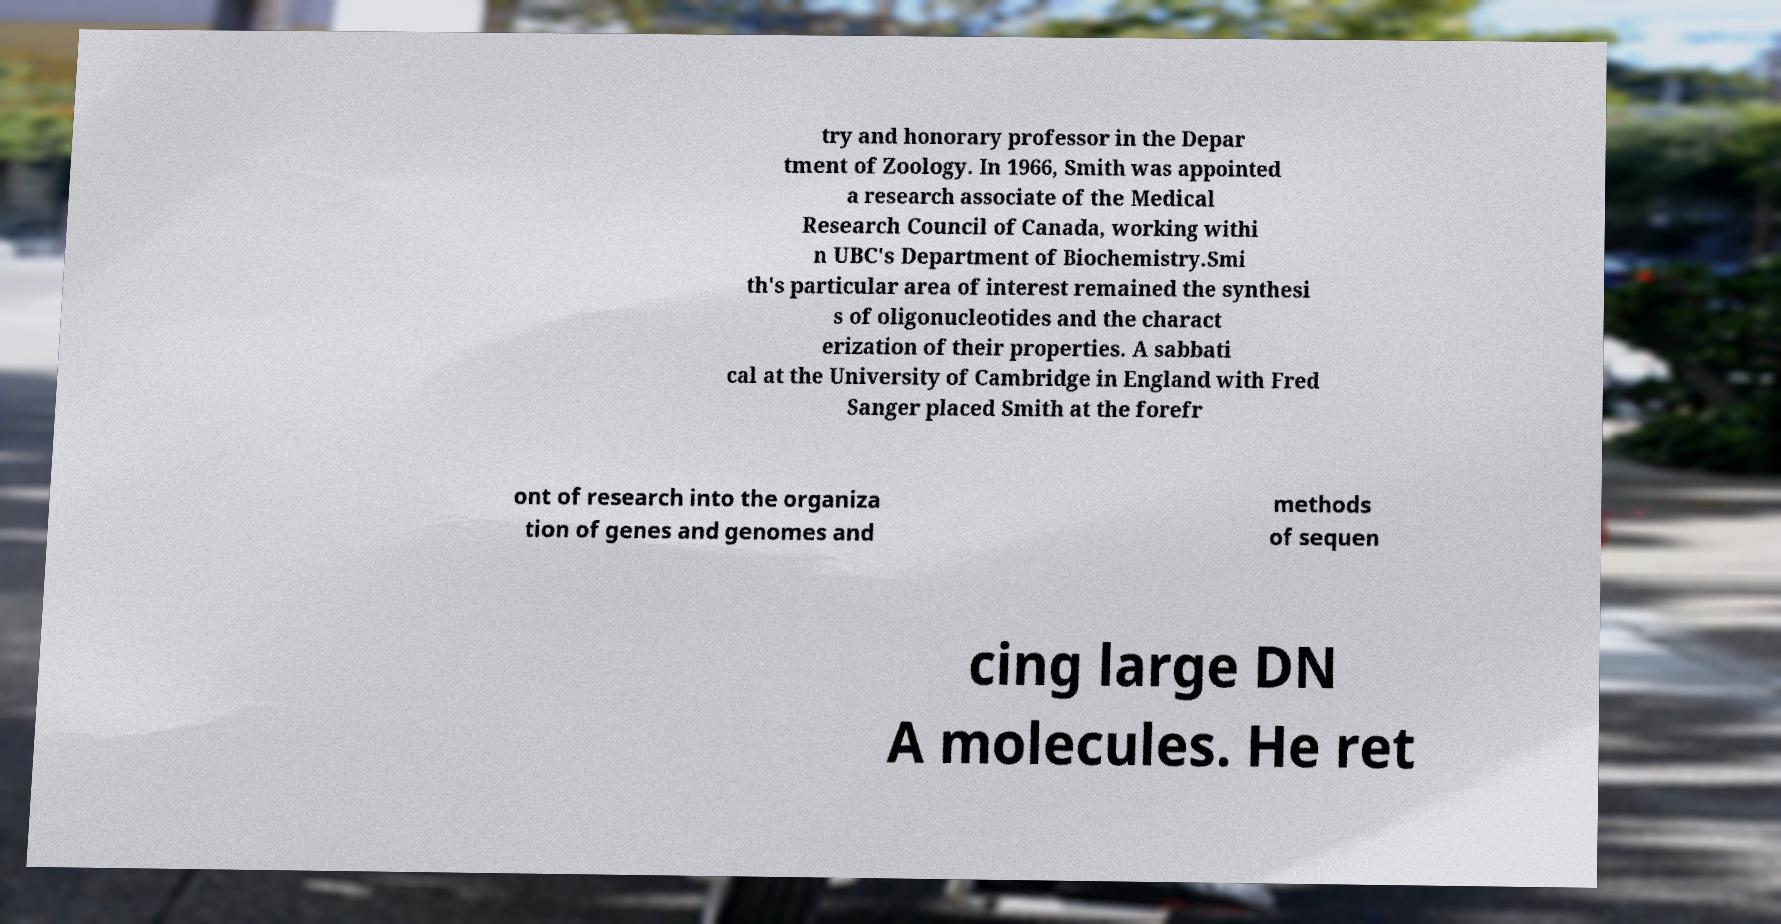Please identify and transcribe the text found in this image. try and honorary professor in the Depar tment of Zoology. In 1966, Smith was appointed a research associate of the Medical Research Council of Canada, working withi n UBC's Department of Biochemistry.Smi th's particular area of interest remained the synthesi s of oligonucleotides and the charact erization of their properties. A sabbati cal at the University of Cambridge in England with Fred Sanger placed Smith at the forefr ont of research into the organiza tion of genes and genomes and methods of sequen cing large DN A molecules. He ret 